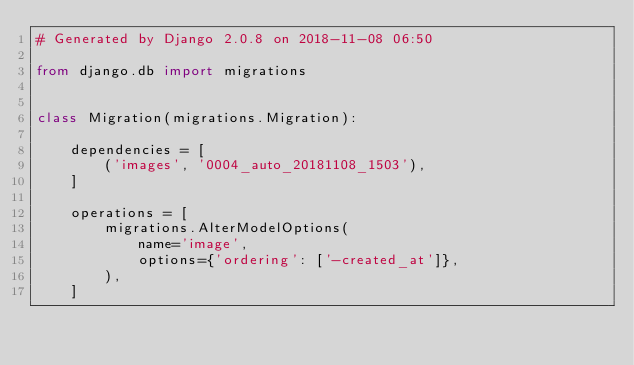Convert code to text. <code><loc_0><loc_0><loc_500><loc_500><_Python_># Generated by Django 2.0.8 on 2018-11-08 06:50

from django.db import migrations


class Migration(migrations.Migration):

    dependencies = [
        ('images', '0004_auto_20181108_1503'),
    ]

    operations = [
        migrations.AlterModelOptions(
            name='image',
            options={'ordering': ['-created_at']},
        ),
    ]
</code> 